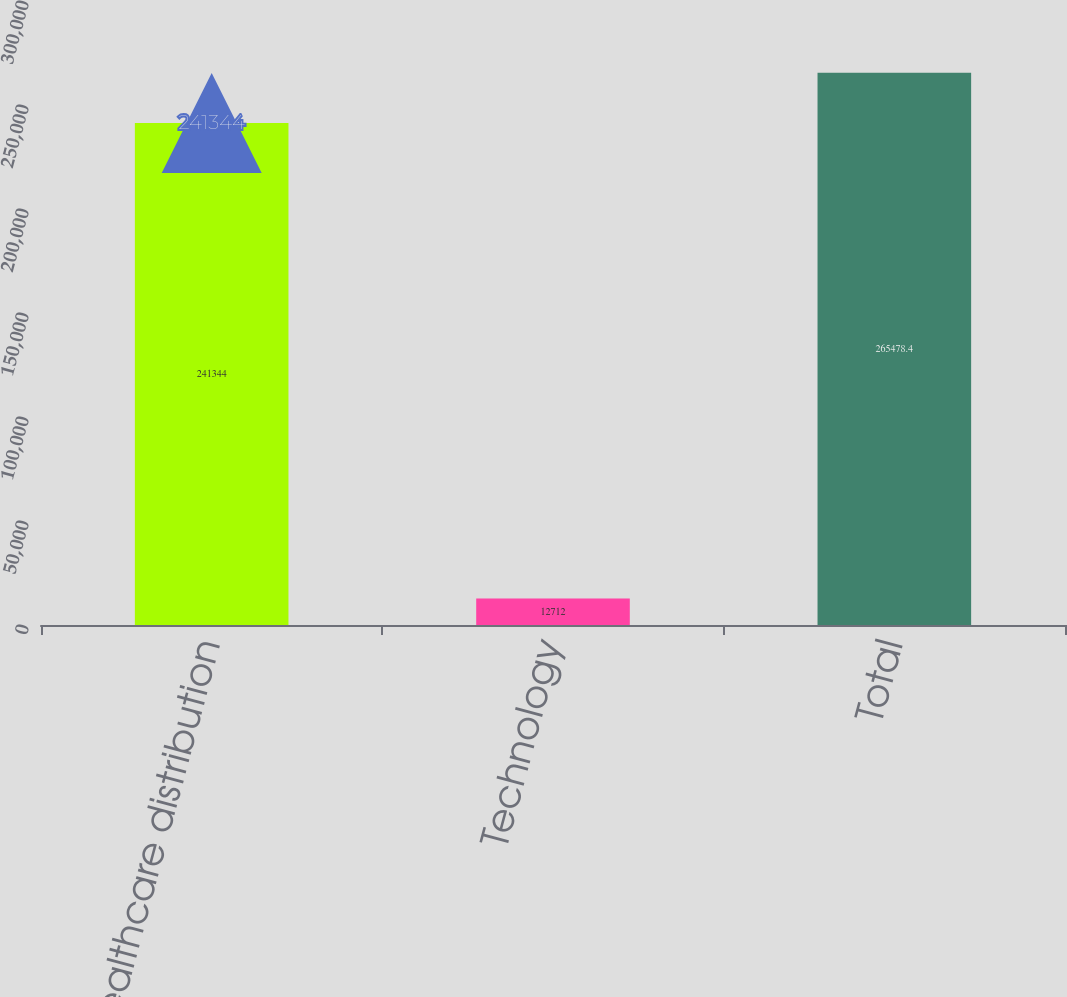<chart> <loc_0><loc_0><loc_500><loc_500><bar_chart><fcel>Healthcare distribution<fcel>Technology<fcel>Total<nl><fcel>241344<fcel>12712<fcel>265478<nl></chart> 